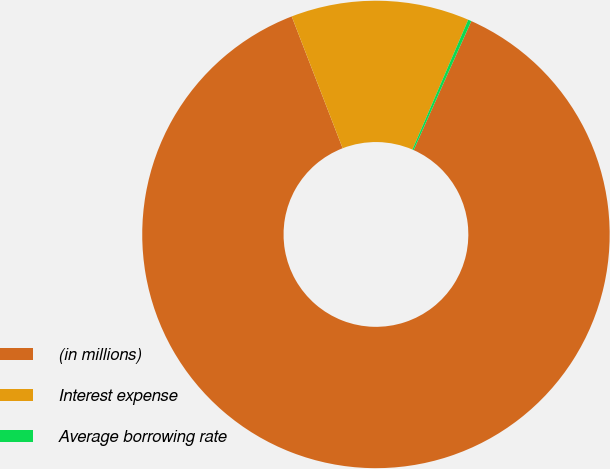Convert chart. <chart><loc_0><loc_0><loc_500><loc_500><pie_chart><fcel>(in millions)<fcel>Interest expense<fcel>Average borrowing rate<nl><fcel>87.45%<fcel>12.33%<fcel>0.23%<nl></chart> 